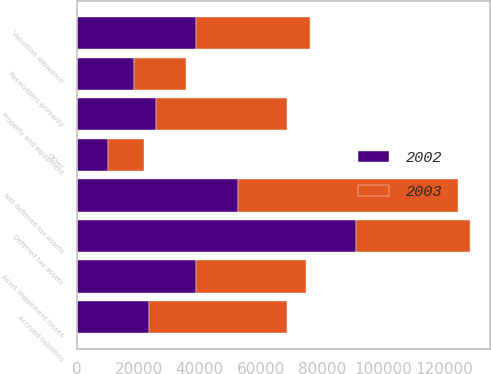Convert chart to OTSL. <chart><loc_0><loc_0><loc_500><loc_500><stacked_bar_chart><ecel><fcel>Asset impairment losses<fcel>Receivables primarily<fcel>Accrued liabilities<fcel>Other<fcel>Deferred tax assets<fcel>Valuation allowance<fcel>Net deferred tax assets<fcel>Property and equipment<nl><fcel>2003<fcel>35817<fcel>16882<fcel>44861<fcel>11683<fcel>37200<fcel>37200<fcel>72043<fcel>42614<nl><fcel>2002<fcel>38844<fcel>18583<fcel>23510<fcel>10124<fcel>91061<fcel>38669<fcel>52392<fcel>25739<nl></chart> 